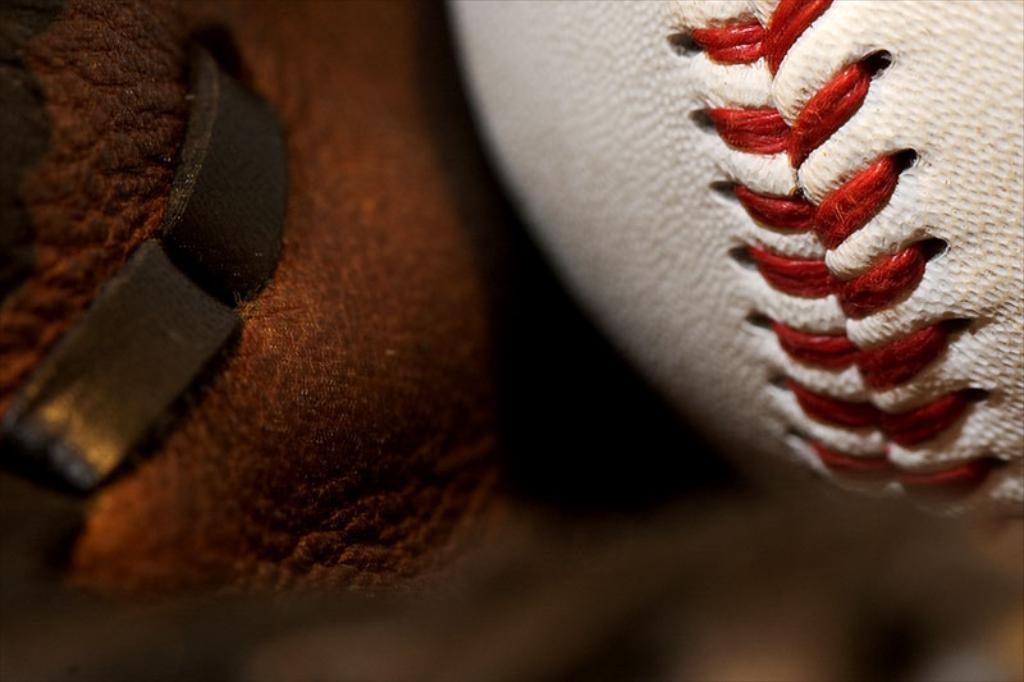What type of ball is visible in the image? There is a rugby ball in the image. Can you describe the object on the left side of the image? The object on the left side of the image is unclear and cannot be definitively described. How does the flock of cubs interact with the rugby ball in the image? There are no cubs or flock present in the image; it only features a rugby ball and an unclear object on the left side. 